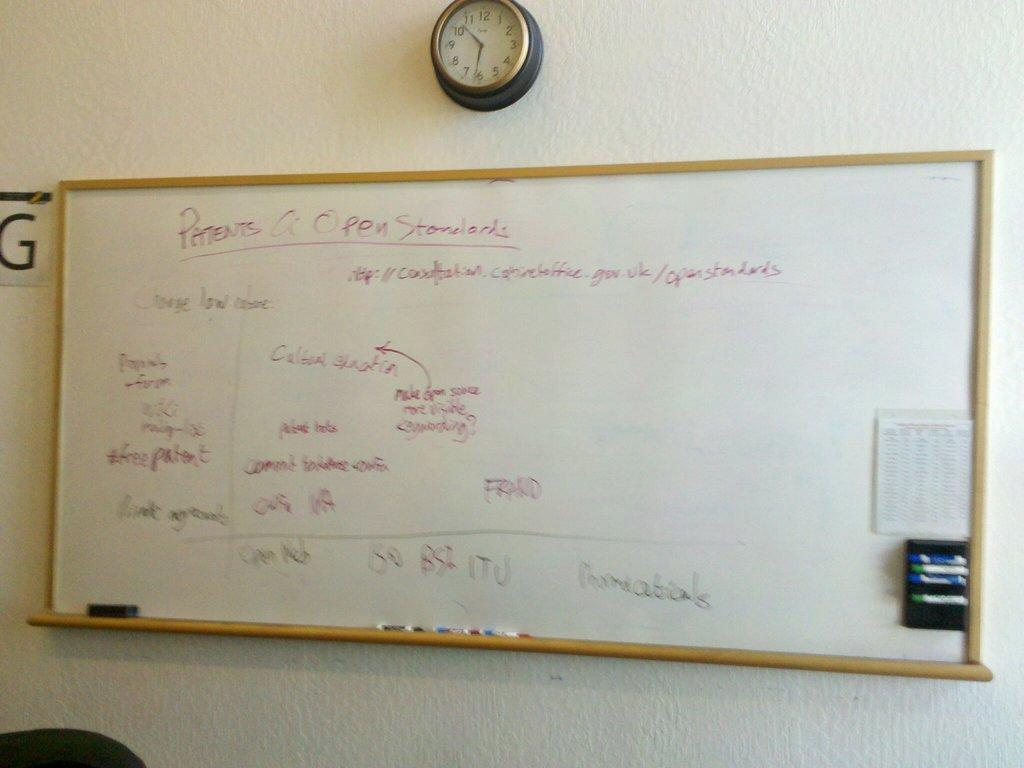<image>
Present a compact description of the photo's key features. A whiteboard with a clock above it, it says Patents in the upper left corner. 